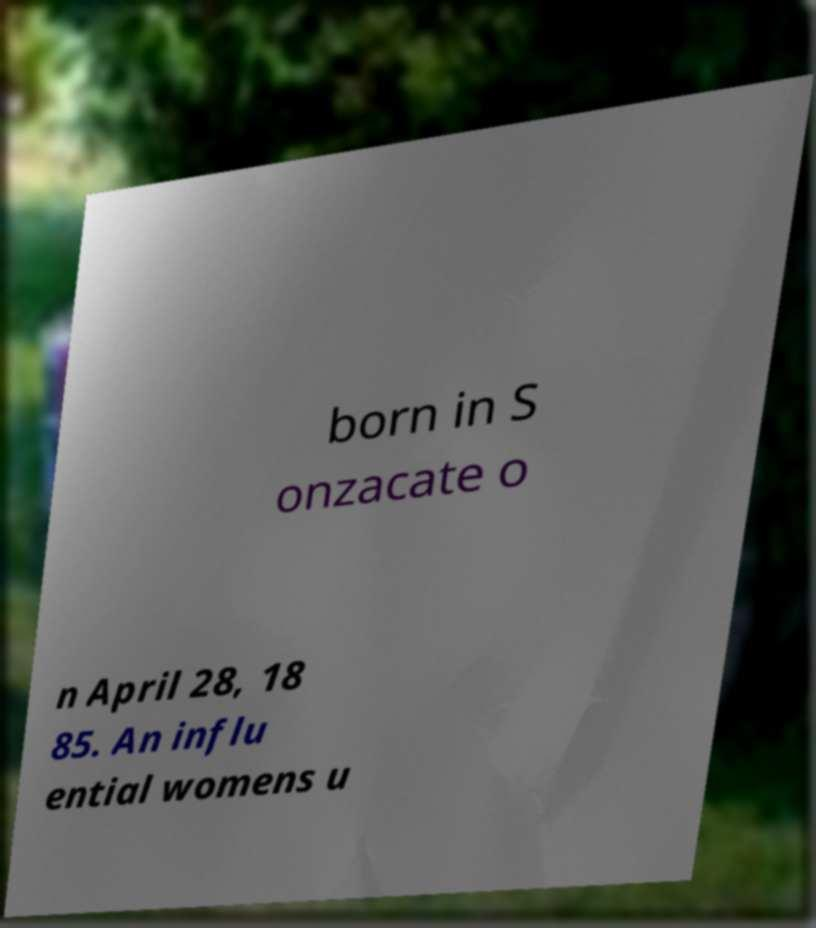Can you read and provide the text displayed in the image?This photo seems to have some interesting text. Can you extract and type it out for me? born in S onzacate o n April 28, 18 85. An influ ential womens u 